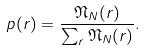Convert formula to latex. <formula><loc_0><loc_0><loc_500><loc_500>p ( r ) = \frac { \mathfrak { N } _ { N } ( r ) } { \sum _ { r } \mathfrak { N } _ { N } ( r ) } .</formula> 